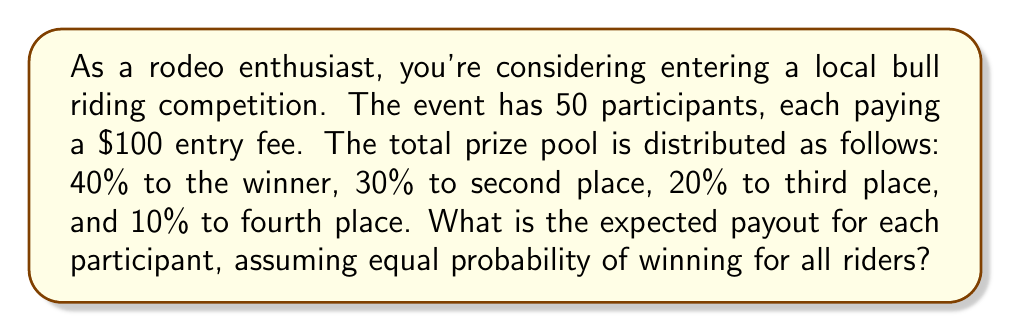Can you answer this question? Let's approach this step-by-step:

1) First, calculate the total prize pool:
   $$ \text{Total Prize Pool} = 50 \text{ participants} \times \$100 \text{ entry fee} = \$5000 $$

2) Now, let's break down the prize distribution:
   $$ \begin{align*}
   1\text{st place}: & 40\% \text{ of } \$5000 = \$2000 \\
   2\text{nd place}: & 30\% \text{ of } \$5000 = \$1500 \\
   3\text{rd place}: & 20\% \text{ of } \$5000 = \$1000 \\
   4\text{th place}: & 10\% \text{ of } \$5000 = \$500
   \end{align*} $$

3) The probability of winning each place is equal for all participants:
   $$ P(\text{winning any place}) = \frac{1}{50} = 0.02 $$

4) Now, we can calculate the expected value. The expected payout is the sum of each possible outcome multiplied by its probability:

   $$ \begin{align*}
   E(\text{payout}) &= 0.02 \times \$2000 + 0.02 \times \$1500 + 0.02 \times \$1000 + 0.02 \times \$500 \\
   &+ 0.92 \times \$0 \text{ (probability of not winning)} \\
   &= \$40 + \$30 + \$20 + \$10 + \$0 \\
   &= \$100
   \end{align*} $$

5) Therefore, the expected payout for each participant is $100, which is equal to the entry fee.
Answer: $100 